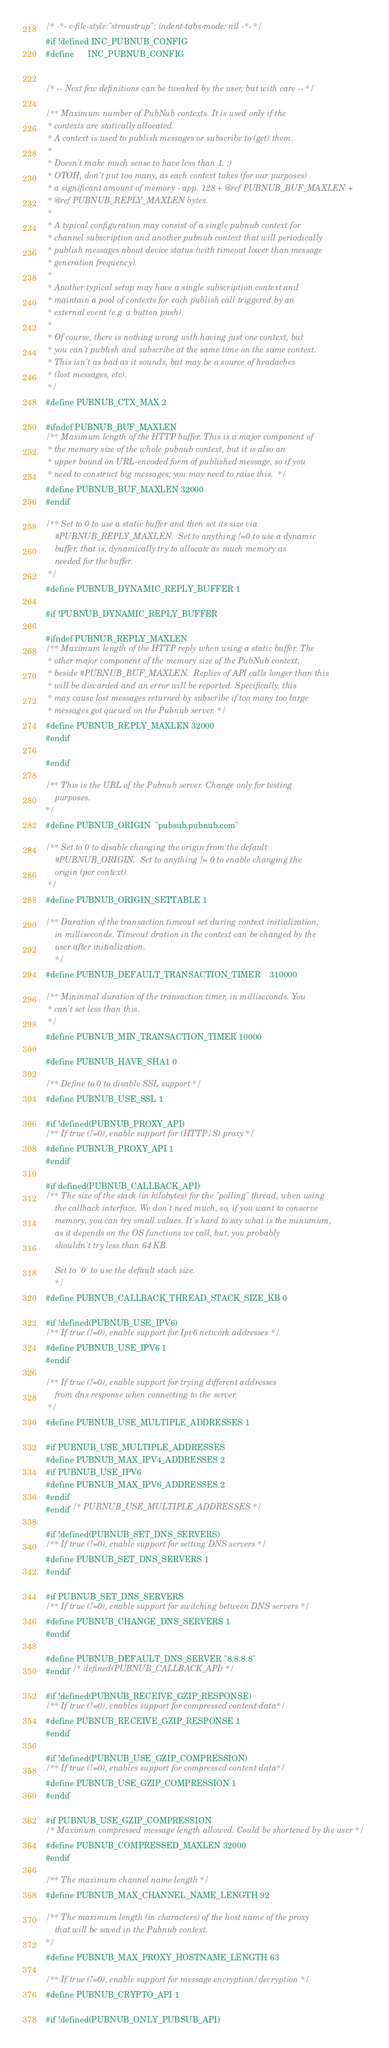Convert code to text. <code><loc_0><loc_0><loc_500><loc_500><_C_>/* -*- c-file-style:"stroustrup"; indent-tabs-mode: nil -*- */
#if !defined INC_PUBNUB_CONFIG
#define      INC_PUBNUB_CONFIG


/* -- Next few definitions can be tweaked by the user, but with care -- */

/** Maximum number of PubNub contexts. It is used only if the
 * contexts are statically allocated.
 * A context is used to publish messages or subscribe to (get) them.
 *
 * Doesn't make much sense to have less than 1. :)
 * OTOH, don't put too many, as each context takes (for our purposes)
 * a significant amount of memory - app. 128 + @ref PUBNUB_BUF_MAXLEN +
 * @ref PUBNUB_REPLY_MAXLEN bytes.
 *
 * A typical configuration may consist of a single pubnub context for
 * channel subscription and another pubnub context that will periodically
 * publish messages about device status (with timeout lower than message
 * generation frequency).
 *
 * Another typical setup may have a single subscription context and
 * maintain a pool of contexts for each publish call triggered by an
 * external event (e.g. a button push).
 *
 * Of course, there is nothing wrong with having just one context, but
 * you can't publish and subscribe at the same time on the same context.
 * This isn't as bad as it sounds, but may be a source of headaches
 * (lost messages, etc).
 */
#define PUBNUB_CTX_MAX 2

#ifndef PUBNUB_BUF_MAXLEN
/** Maximum length of the HTTP buffer. This is a major component of
 * the memory size of the whole pubnub context, but it is also an
 * upper bound on URL-encoded form of published message, so if you
 * need to construct big messages, you may need to raise this.  */
#define PUBNUB_BUF_MAXLEN 32000
#endif

/** Set to 0 to use a static buffer and then set its size via
    #PUBNUB_REPLY_MAXLEN.  Set to anything !=0 to use a dynamic
    buffer, that is, dynamically try to allocate as much memory as
    needed for the buffer.
 */
#define PUBNUB_DYNAMIC_REPLY_BUFFER 1

#if !PUBNUB_DYNAMIC_REPLY_BUFFER

#ifndef PUBNUB_REPLY_MAXLEN
/** Maximum length of the HTTP reply when using a static buffer. The
 * other major component of the memory size of the PubNub context,
 * beside #PUBNUB_BUF_MAXLEN.  Replies of API calls longer than this
 * will be discarded and an error will be reported. Specifically, this
 * may cause lost messages returned by subscribe if too many too large
 * messages got queued on the Pubnub server. */
#define PUBNUB_REPLY_MAXLEN 32000
#endif

#endif

/** This is the URL of the Pubnub server. Change only for testing
    purposes.
*/
#define PUBNUB_ORIGIN  "pubsub.pubnub.com"

/** Set to 0 to disable changing the origin from the default
    #PUBNUB_ORIGIN.  Set to anything != 0 to enable changing the
    origin (per context).
 */
#define PUBNUB_ORIGIN_SETTABLE 1

/** Duration of the transaction timeout set during context initialization,
    in milliseconds. Timeout dration in the context can be changed by the 
    user after initialization.
    */
#define PUBNUB_DEFAULT_TRANSACTION_TIMER    310000

/** Mininmal duration of the transaction timer, in milliseconds. You
 * can't set less than this.
 */
#define PUBNUB_MIN_TRANSACTION_TIMER 10000

#define PUBNUB_HAVE_SHA1 0

/** Define to 0 to disable SSL support */
#define PUBNUB_USE_SSL 1

#if !defined(PUBNUB_PROXY_API)
/** If true (!=0), enable support for (HTTP/S) proxy */
#define PUBNUB_PROXY_API 1
#endif

#if defined(PUBNUB_CALLBACK_API)
/** The size of the stack (in kilobytes) for the "polling" thread, when using 
    the callback interface. We don't need much, so, if you want to conserve 
    memory, you can try small values. It's hard to say what is the minumum, 
    as it depends on the OS functions we call, but, you probably 
    shouldn't try less than 64 KB.
    
    Set to `0` to use the default stack size.
    */
#define PUBNUB_CALLBACK_THREAD_STACK_SIZE_KB 0

#if !defined(PUBNUB_USE_IPV6)
/** If true (!=0), enable support for Ipv6 network addresses */
#define PUBNUB_USE_IPV6 1
#endif

/** If true (!=0), enable support for trying different addresses
    from dns response when connecting to the server.
 */
#define PUBNUB_USE_MULTIPLE_ADDRESSES 1

#if PUBNUB_USE_MULTIPLE_ADDRESSES
#define PUBNUB_MAX_IPV4_ADDRESSES 2
#if PUBNUB_USE_IPV6
#define PUBNUB_MAX_IPV6_ADDRESSES 2
#endif
#endif /* PUBNUB_USE_MULTIPLE_ADDRESSES */

#if !defined(PUBNUB_SET_DNS_SERVERS)
/** If true (!=0), enable support for setting DNS servers */
#define PUBNUB_SET_DNS_SERVERS 1
#endif

#if PUBNUB_SET_DNS_SERVERS
/** If true (!=0), enable support for switching between DNS servers */
#define PUBNUB_CHANGE_DNS_SERVERS 1
#endif

#define PUBNUB_DEFAULT_DNS_SERVER "8.8.8.8"
#endif /* defined(PUBNUB_CALLBACK_API) */

#if !defined(PUBNUB_RECEIVE_GZIP_RESPONSE)
/** If true (!=0), enables support for compressed content data*/
#define PUBNUB_RECEIVE_GZIP_RESPONSE 1
#endif

#if !defined(PUBNUB_USE_GZIP_COMPRESSION)
/** If true (!=0), enables support for compressed content data*/
#define PUBNUB_USE_GZIP_COMPRESSION 1
#endif

#if PUBNUB_USE_GZIP_COMPRESSION
/* Maximum compressed message length allowed. Could be shortened by the user */
#define PUBNUB_COMPRESSED_MAXLEN 32000
#endif

/** The maximum channel name length */
#define PUBNUB_MAX_CHANNEL_NAME_LENGTH 92

/** The maximum length (in characters) of the host name of the proxy
    that will be saved in the Pubnub context.
*/
#define PUBNUB_MAX_PROXY_HOSTNAME_LENGTH 63

/** If true (!=0), enable support for message encryption/decryption */
#define PUBNUB_CRYPTO_API 1

#if !defined(PUBNUB_ONLY_PUBSUB_API)</code> 